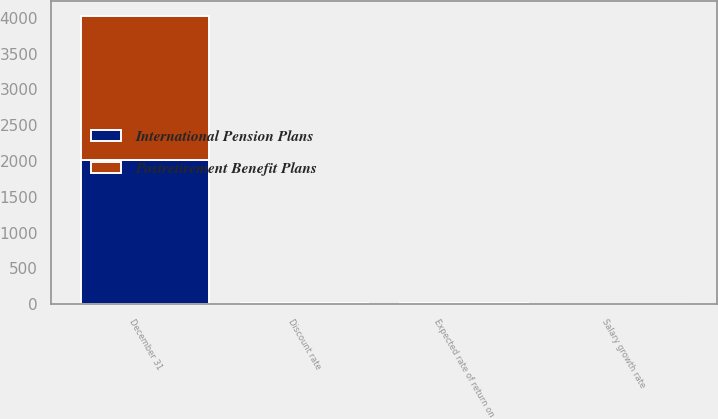<chart> <loc_0><loc_0><loc_500><loc_500><stacked_bar_chart><ecel><fcel>December 31<fcel>Discount rate<fcel>Expected rate of return on<fcel>Salary growth rate<nl><fcel>Postretirement Benefit Plans<fcel>2014<fcel>4.9<fcel>8.5<fcel>4.5<nl><fcel>International Pension Plans<fcel>2014<fcel>3.8<fcel>6<fcel>3.1<nl></chart> 